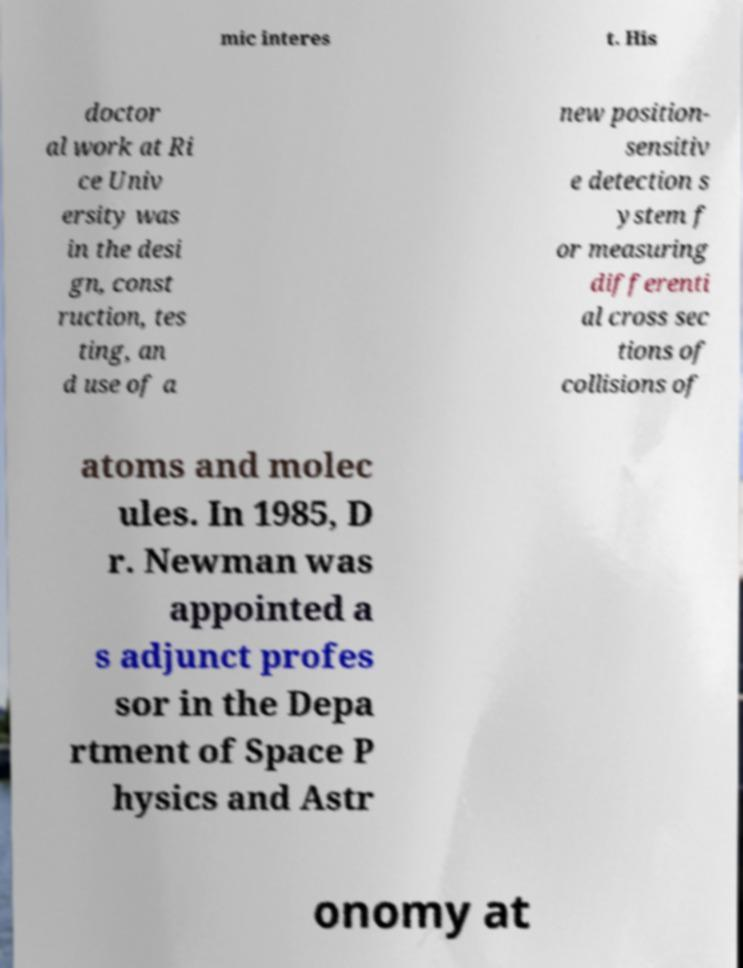Could you assist in decoding the text presented in this image and type it out clearly? mic interes t. His doctor al work at Ri ce Univ ersity was in the desi gn, const ruction, tes ting, an d use of a new position- sensitiv e detection s ystem f or measuring differenti al cross sec tions of collisions of atoms and molec ules. In 1985, D r. Newman was appointed a s adjunct profes sor in the Depa rtment of Space P hysics and Astr onomy at 